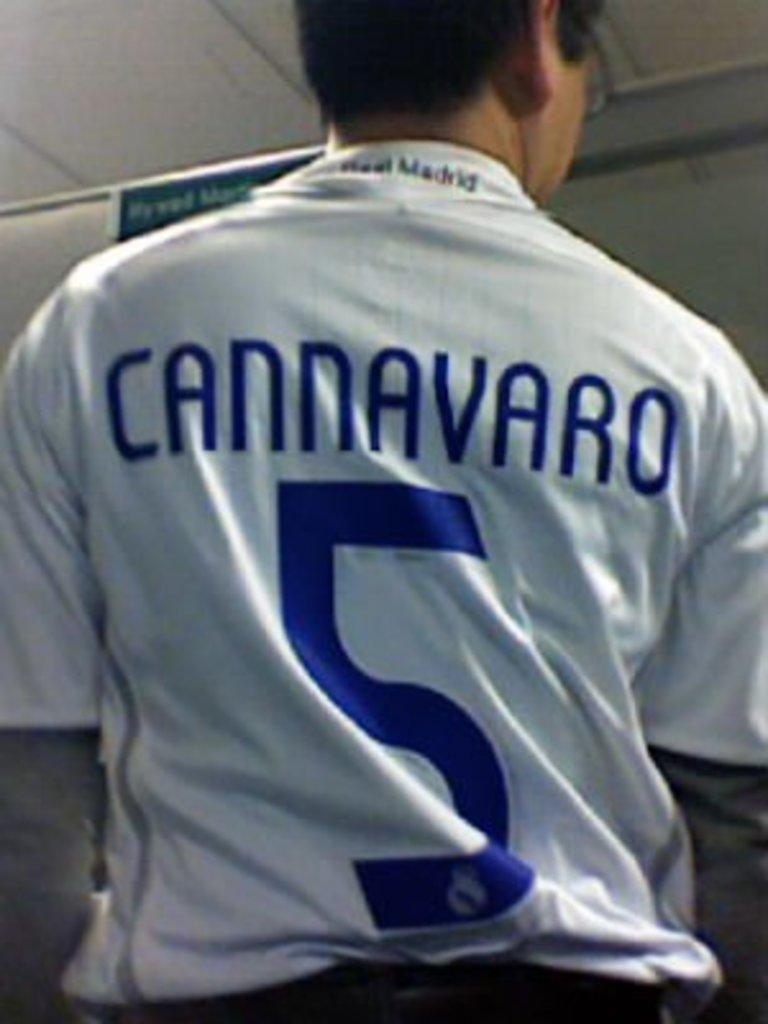<image>
Describe the image concisely. A man wearing a number 5 Cannavaro jersey stand with his back towards the camera 